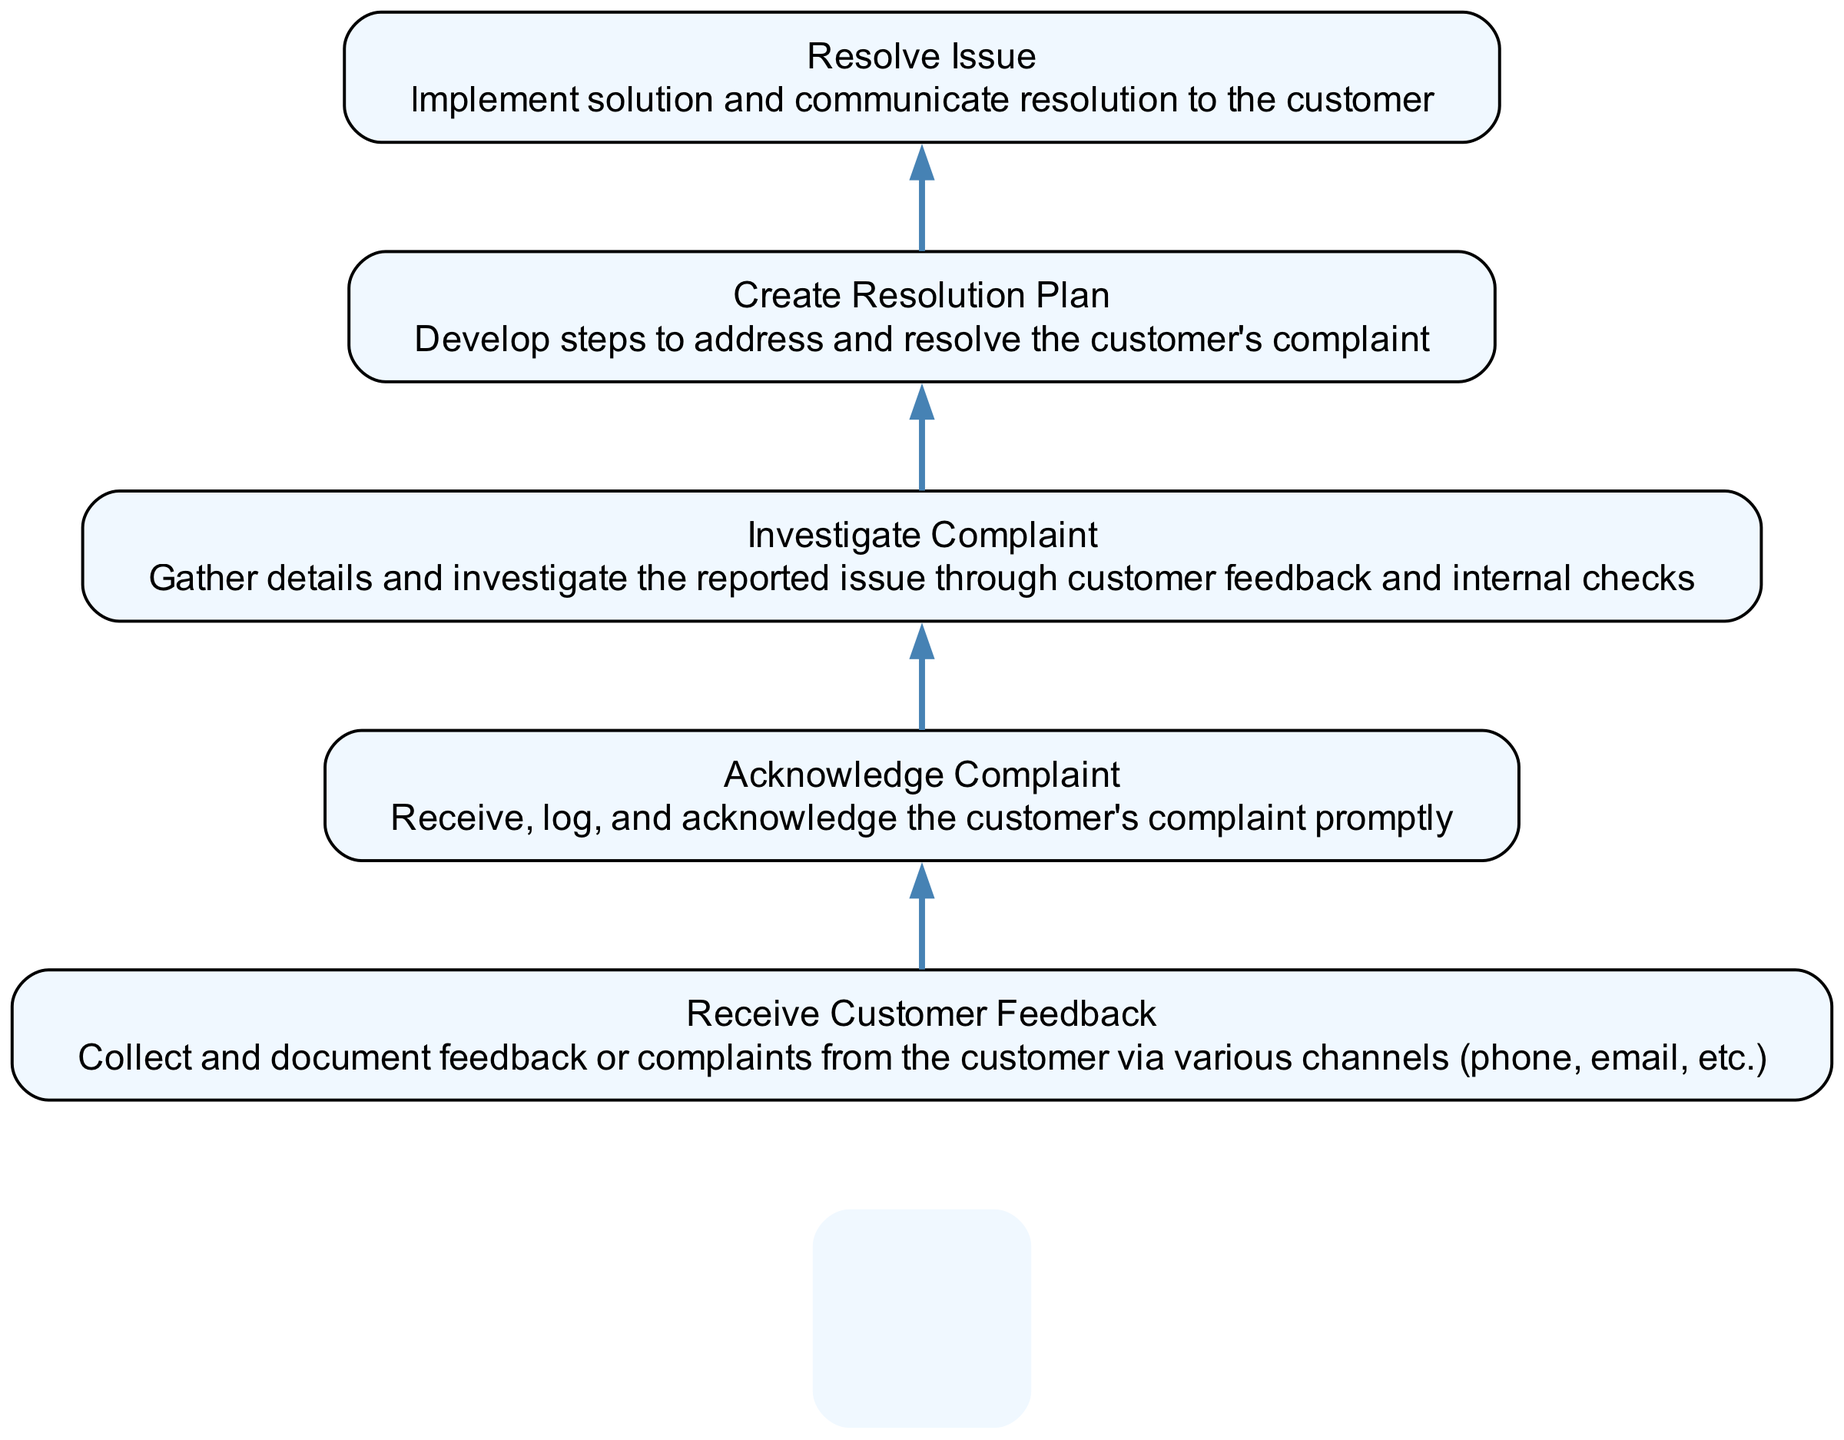What is the top node in the flowchart? The top node represents the final step in the process, which is to "Resolve Issue." This is the highest point in the diagram, indicating that this is the concluding action that follows all previous steps.
Answer: Resolve Issue How many nodes are in the diagram? The diagram contains five nodes that represent different steps in the customer feedback process. Each node corresponds to a specific action within the process.
Answer: Five What is the first step in the customer feedback process? The first step as depicted in the diagram is "Receive Customer Feedback." This indicates where the process begins with the collection of information from the customer.
Answer: Receive Customer Feedback What action follows "Acknowledge Complaint"? The action that follows "Acknowledge Complaint" is "Investigate Complaint." This shows the progression from receiving the complaint to looking into its details.
Answer: Investigate Complaint How many total edges connect the nodes in the flowchart? There are four edges in the diagram, as each node (except the topmost) connects to its preceding step, creating a directed flow.
Answer: Four Which nodes are directly connected? The nodes are connected in the following sequence: "Receive Customer Feedback" to "Acknowledge Complaint," "Acknowledge Complaint" to "Investigate Complaint," "Investigate Complaint" to "Create Resolution Plan," and "Create Resolution Plan" to "Resolve Issue." This signifies the direct flow of actions.
Answer: All nodes are directly connected in sequence What is the primary purpose of the node "Create Resolution Plan"? The primary purpose of the node "Create Resolution Plan" is to develop steps to address and resolve the customer's complaint, making it crucial for the resolution process that follows.
Answer: Develop steps to address and resolve the customer's complaint What is the geometric orientation of the flow in the diagram? The orientation shows a bottom-to-top flow, meaning the process begins at the bottom and progresses upward through the nodes sequentially.
Answer: Bottom-to-top What does the image of the postman signify in the diagram? The image of the postman serves as a decorative element and symbolizes the overarching customer service aspect of delivering solutions and communications, reflecting the theme of customer engagement.
Answer: Customer service symbolism 